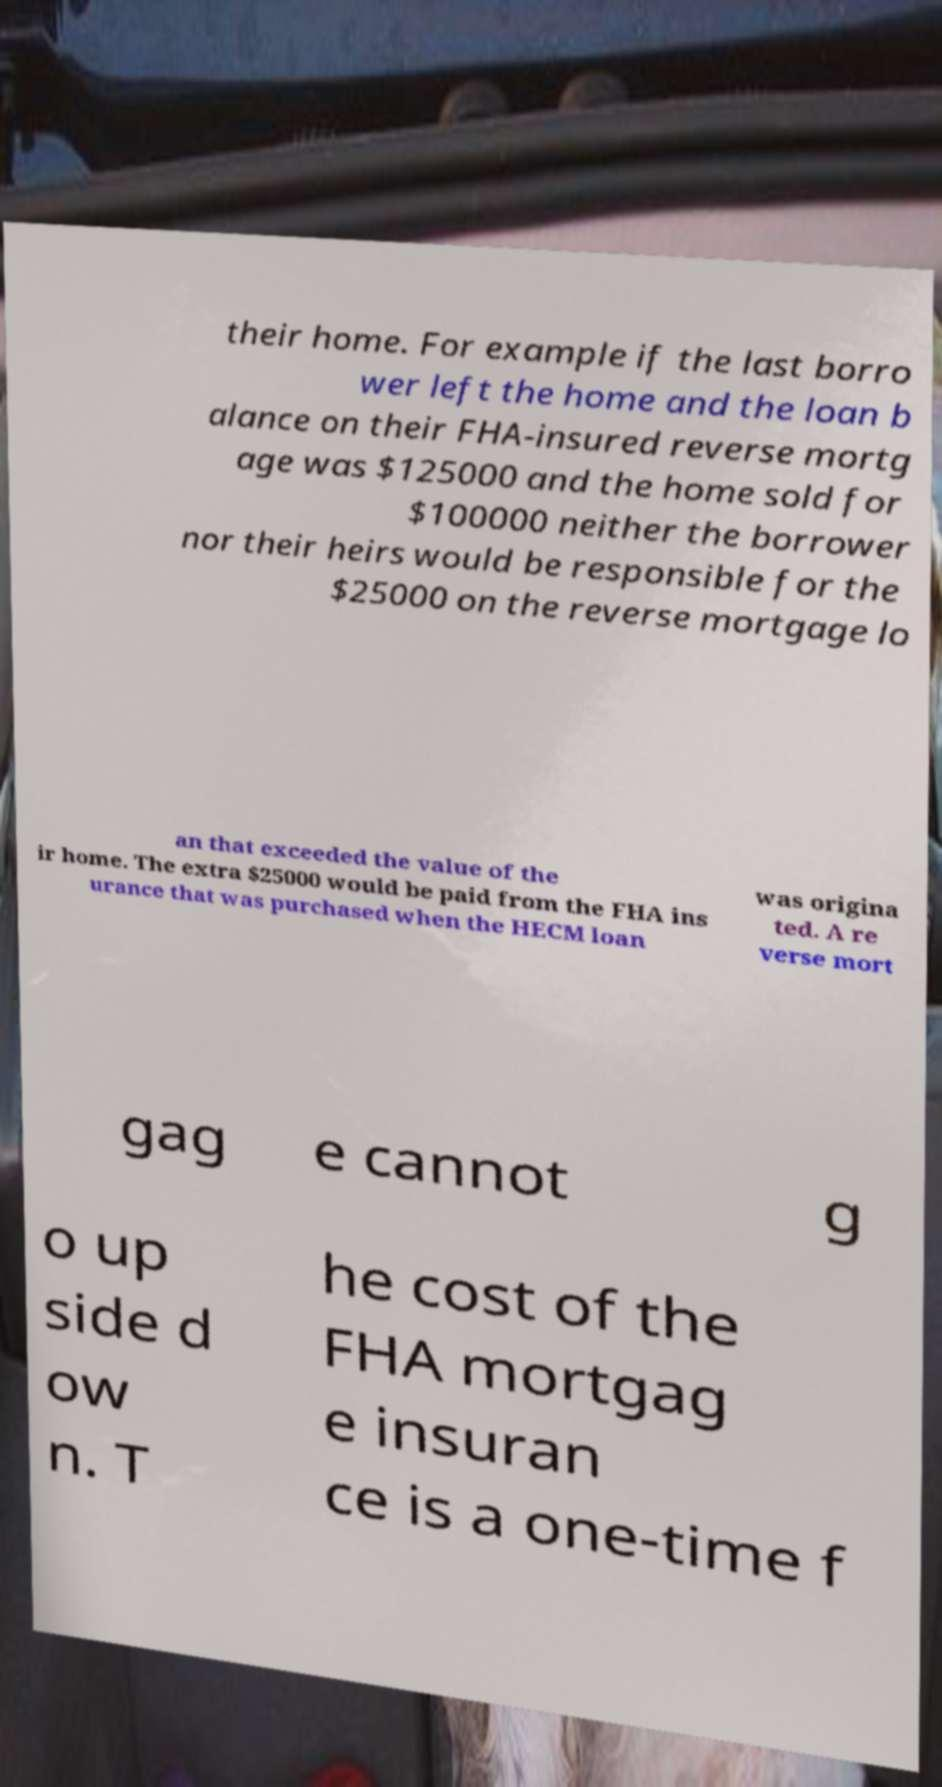Can you read and provide the text displayed in the image?This photo seems to have some interesting text. Can you extract and type it out for me? their home. For example if the last borro wer left the home and the loan b alance on their FHA-insured reverse mortg age was $125000 and the home sold for $100000 neither the borrower nor their heirs would be responsible for the $25000 on the reverse mortgage lo an that exceeded the value of the ir home. The extra $25000 would be paid from the FHA ins urance that was purchased when the HECM loan was origina ted. A re verse mort gag e cannot g o up side d ow n. T he cost of the FHA mortgag e insuran ce is a one-time f 